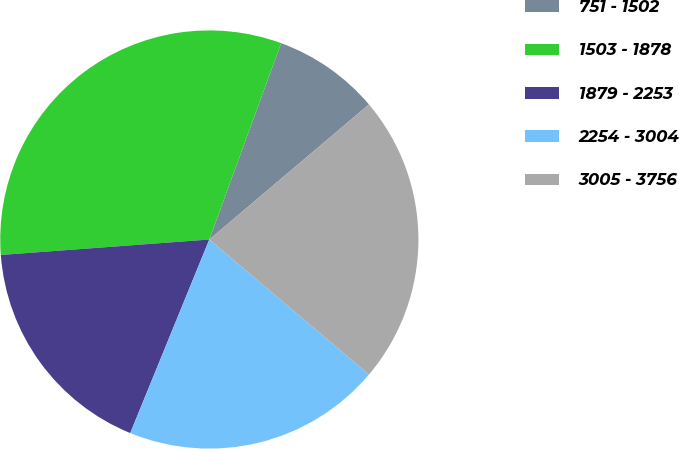<chart> <loc_0><loc_0><loc_500><loc_500><pie_chart><fcel>751 - 1502<fcel>1503 - 1878<fcel>1879 - 2253<fcel>2254 - 3004<fcel>3005 - 3756<nl><fcel>8.24%<fcel>31.76%<fcel>17.65%<fcel>20.0%<fcel>22.35%<nl></chart> 